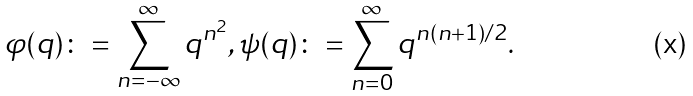Convert formula to latex. <formula><loc_0><loc_0><loc_500><loc_500>\varphi ( q ) \colon = \sum _ { n = - \infty } ^ { \infty } q ^ { n ^ { 2 } } , \psi ( q ) \colon = \sum _ { n = 0 } ^ { \infty } q ^ { n ( n + 1 ) / 2 } .</formula> 